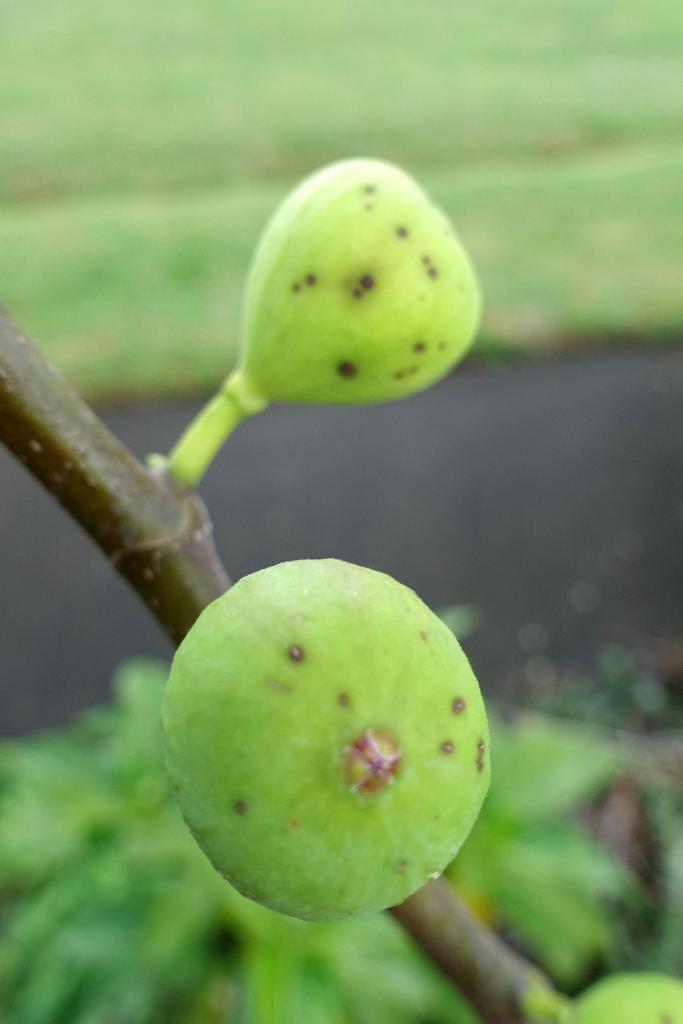What type of food can be seen in the image? There are fruits in the image. What can be seen in the background of the image? There are plants and some objects in the background of the image. Can you describe the quality of the image? The image is blurry. How many veins can be seen on the rabbits in the image? There are no rabbits present in the image, so it is not possible to determine the number of veins on them. 